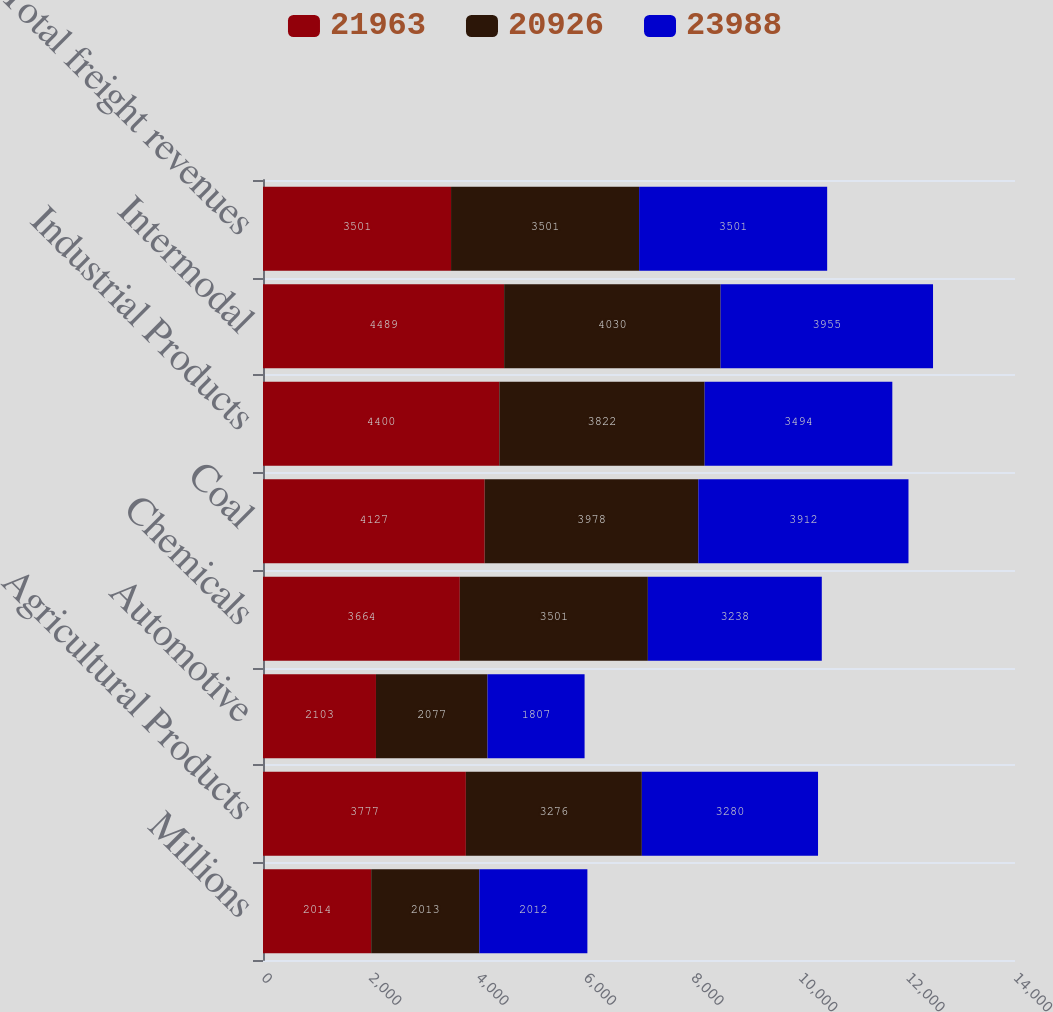Convert chart to OTSL. <chart><loc_0><loc_0><loc_500><loc_500><stacked_bar_chart><ecel><fcel>Millions<fcel>Agricultural Products<fcel>Automotive<fcel>Chemicals<fcel>Coal<fcel>Industrial Products<fcel>Intermodal<fcel>Total freight revenues<nl><fcel>21963<fcel>2014<fcel>3777<fcel>2103<fcel>3664<fcel>4127<fcel>4400<fcel>4489<fcel>3501<nl><fcel>20926<fcel>2013<fcel>3276<fcel>2077<fcel>3501<fcel>3978<fcel>3822<fcel>4030<fcel>3501<nl><fcel>23988<fcel>2012<fcel>3280<fcel>1807<fcel>3238<fcel>3912<fcel>3494<fcel>3955<fcel>3501<nl></chart> 